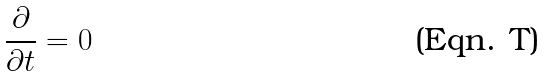<formula> <loc_0><loc_0><loc_500><loc_500>\frac { \partial } { \partial t } = 0</formula> 